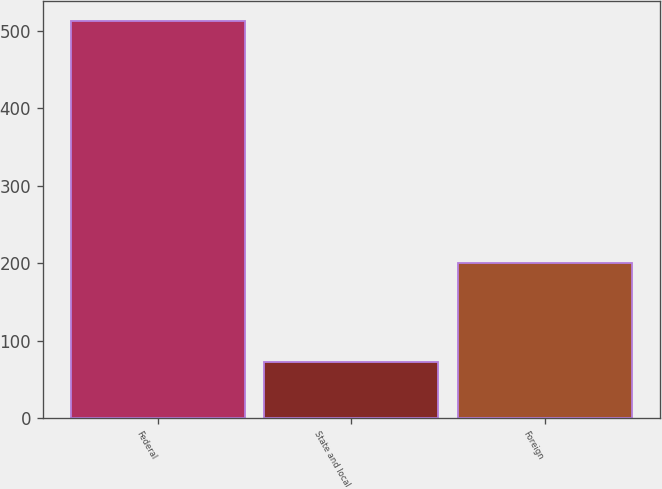<chart> <loc_0><loc_0><loc_500><loc_500><bar_chart><fcel>Federal<fcel>State and local<fcel>Foreign<nl><fcel>513<fcel>72<fcel>200<nl></chart> 